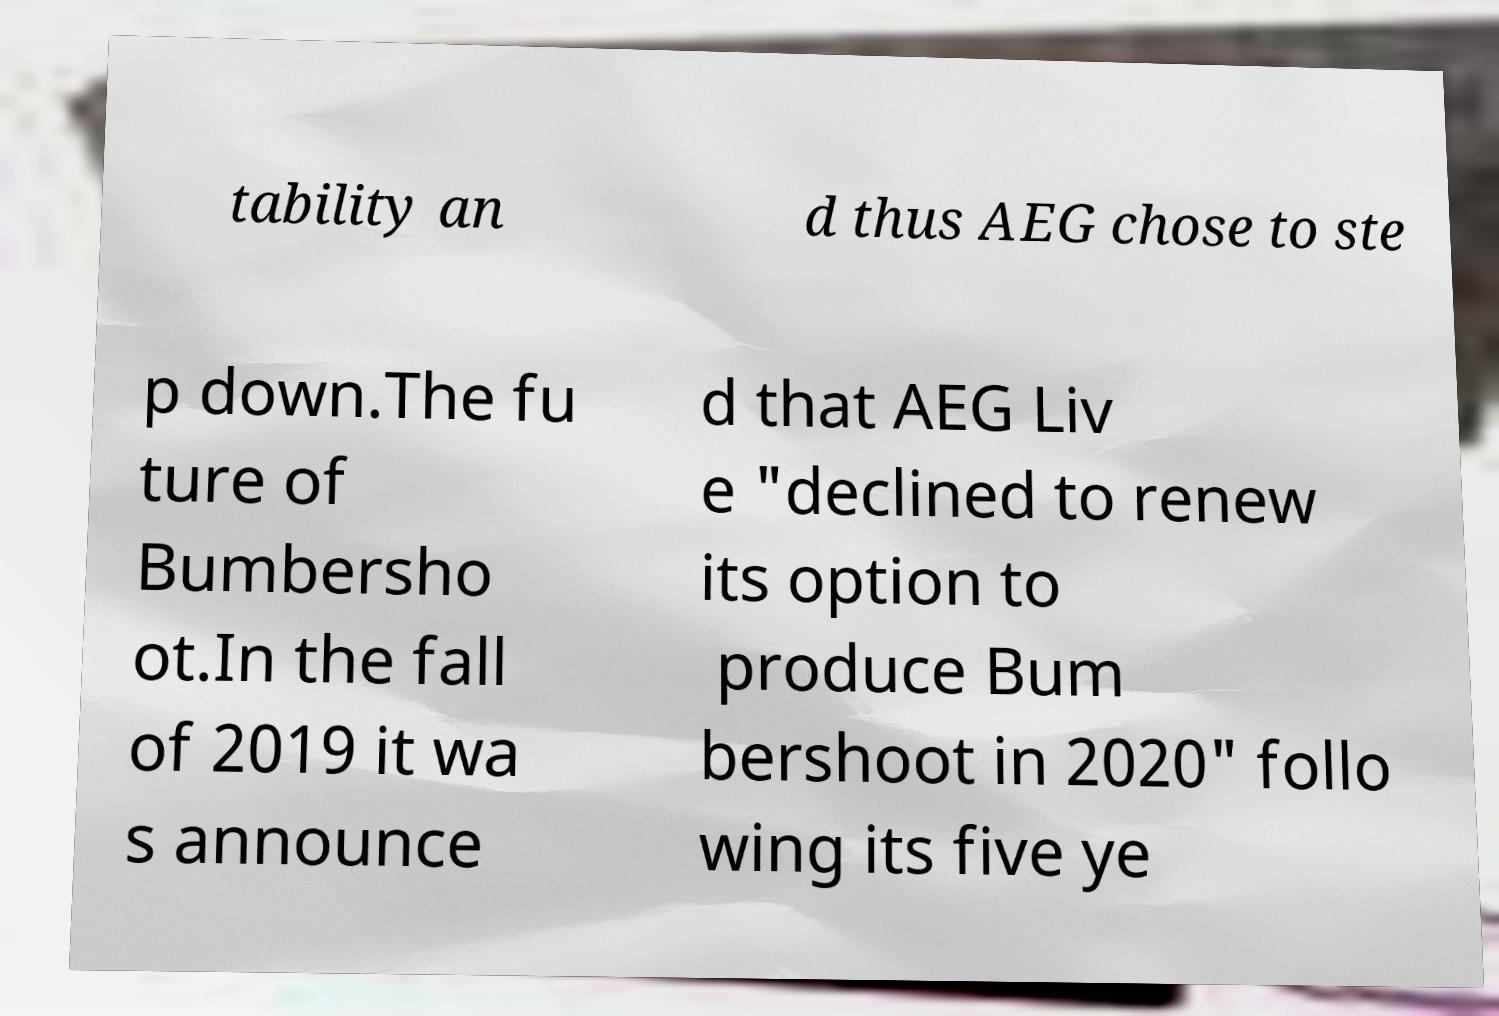Please identify and transcribe the text found in this image. tability an d thus AEG chose to ste p down.The fu ture of Bumbersho ot.In the fall of 2019 it wa s announce d that AEG Liv e "declined to renew its option to produce Bum bershoot in 2020" follo wing its five ye 